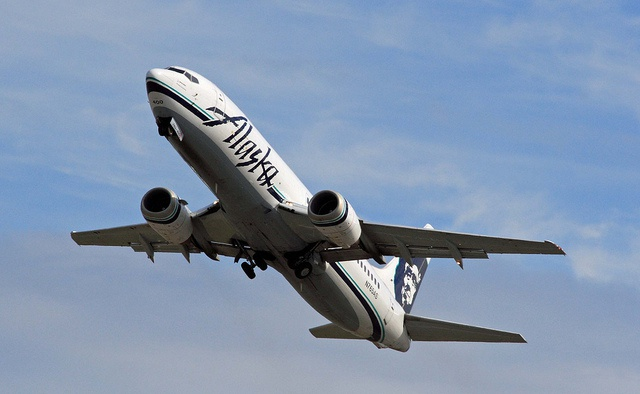Describe the objects in this image and their specific colors. I can see a airplane in darkgray, black, lightgray, and gray tones in this image. 